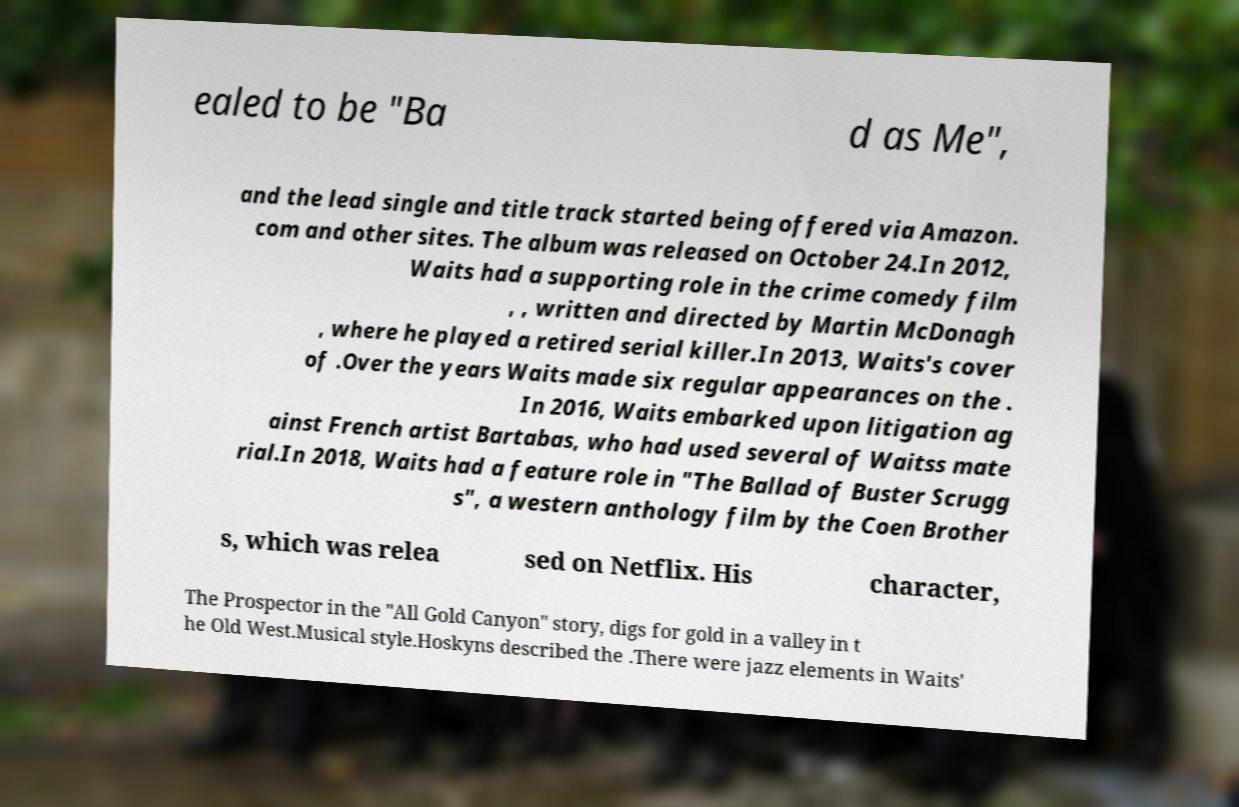I need the written content from this picture converted into text. Can you do that? ealed to be "Ba d as Me", and the lead single and title track started being offered via Amazon. com and other sites. The album was released on October 24.In 2012, Waits had a supporting role in the crime comedy film , , written and directed by Martin McDonagh , where he played a retired serial killer.In 2013, Waits's cover of .Over the years Waits made six regular appearances on the . In 2016, Waits embarked upon litigation ag ainst French artist Bartabas, who had used several of Waitss mate rial.In 2018, Waits had a feature role in "The Ballad of Buster Scrugg s", a western anthology film by the Coen Brother s, which was relea sed on Netflix. His character, The Prospector in the "All Gold Canyon" story, digs for gold in a valley in t he Old West.Musical style.Hoskyns described the .There were jazz elements in Waits' 